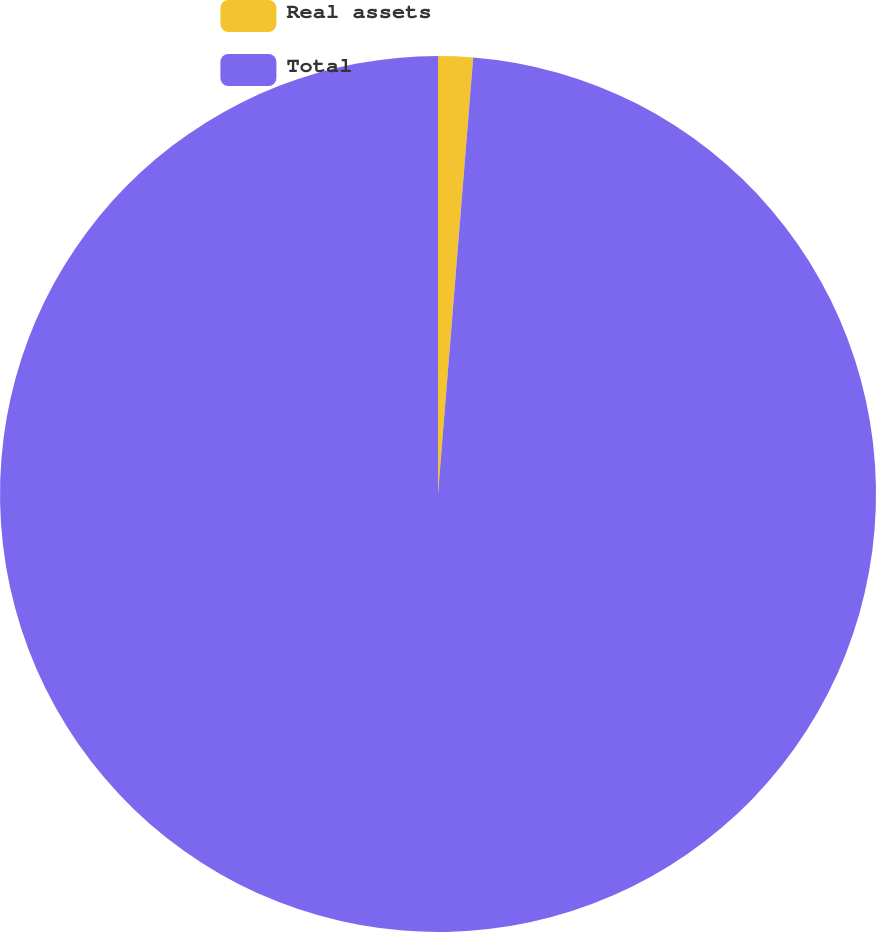Convert chart to OTSL. <chart><loc_0><loc_0><loc_500><loc_500><pie_chart><fcel>Real assets<fcel>Total<nl><fcel>1.28%<fcel>98.72%<nl></chart> 